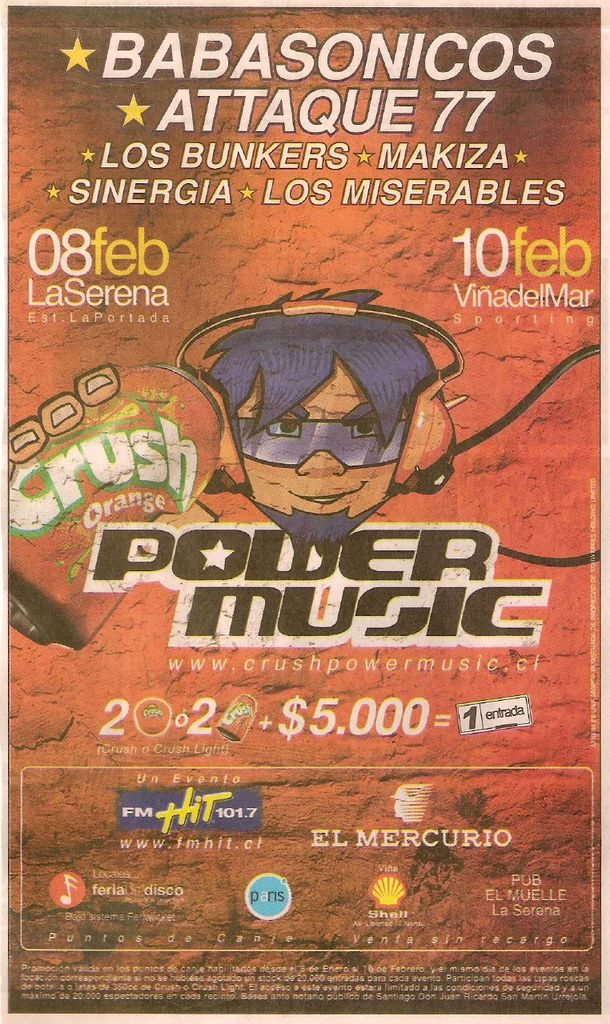Can you list all the bands featured in this festival poster? The poster features Babasonic, Attaque 77, Los Bunkers, Makiza, Sinergia, and Los Miserales. What are the dates and locations for this event? The event is scheduled for February 8th at La Serena, Estadio La Portada and February 10th at Vina del Mar, Sporting. 